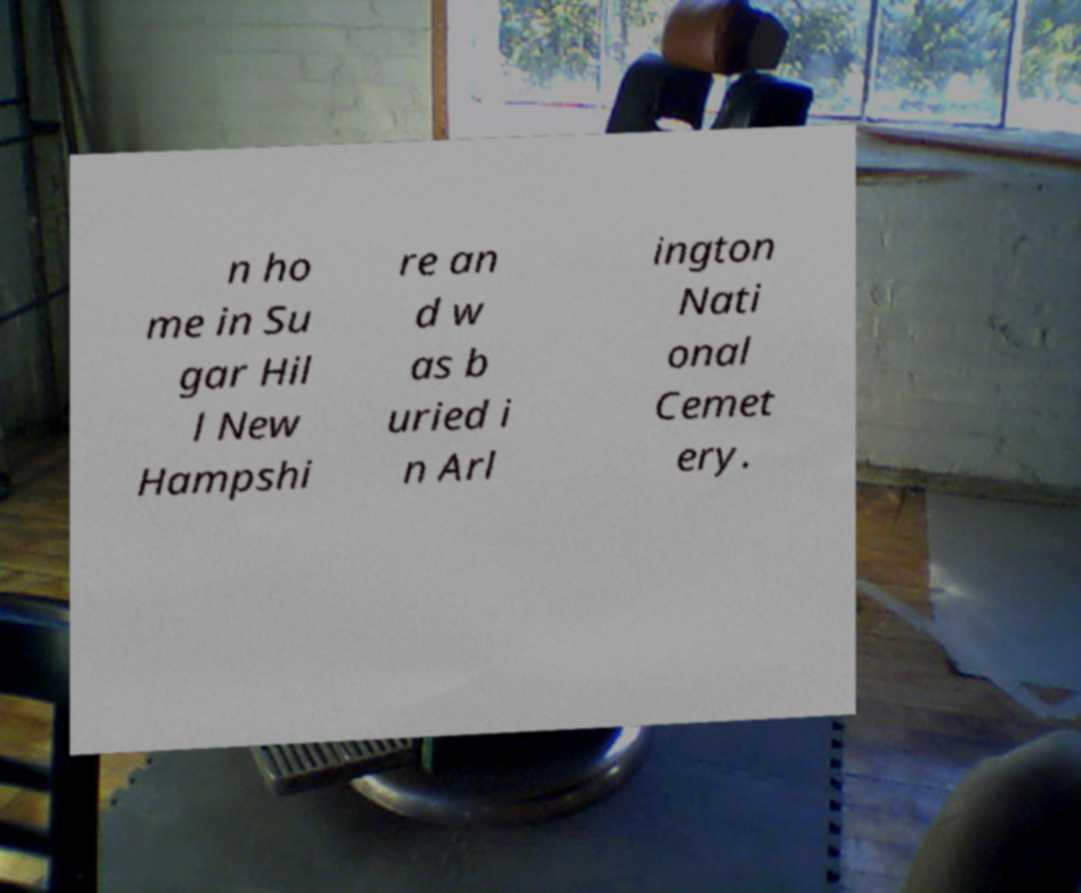I need the written content from this picture converted into text. Can you do that? n ho me in Su gar Hil l New Hampshi re an d w as b uried i n Arl ington Nati onal Cemet ery. 